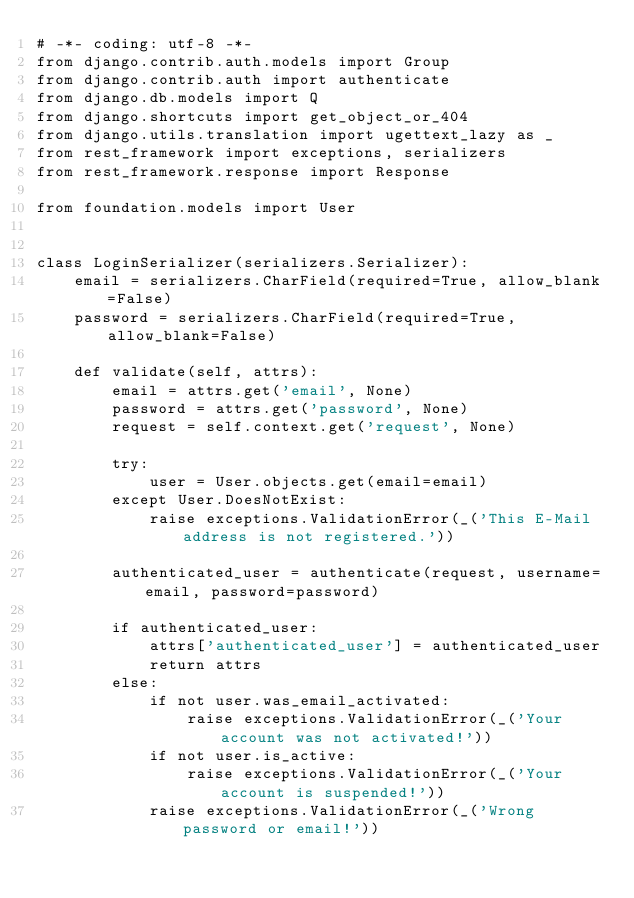<code> <loc_0><loc_0><loc_500><loc_500><_Python_># -*- coding: utf-8 -*-
from django.contrib.auth.models import Group
from django.contrib.auth import authenticate
from django.db.models import Q
from django.shortcuts import get_object_or_404
from django.utils.translation import ugettext_lazy as _
from rest_framework import exceptions, serializers
from rest_framework.response import Response

from foundation.models import User


class LoginSerializer(serializers.Serializer):
    email = serializers.CharField(required=True, allow_blank=False)
    password = serializers.CharField(required=True, allow_blank=False)

    def validate(self, attrs):
        email = attrs.get('email', None)
        password = attrs.get('password', None)
        request = self.context.get('request', None)

        try:
            user = User.objects.get(email=email)
        except User.DoesNotExist:
            raise exceptions.ValidationError(_('This E-Mail address is not registered.'))

        authenticated_user = authenticate(request, username=email, password=password)

        if authenticated_user:
            attrs['authenticated_user'] = authenticated_user
            return attrs
        else:
            if not user.was_email_activated:
                raise exceptions.ValidationError(_('Your account was not activated!'))
            if not user.is_active:
                raise exceptions.ValidationError(_('Your account is suspended!'))
            raise exceptions.ValidationError(_('Wrong password or email!'))
</code> 